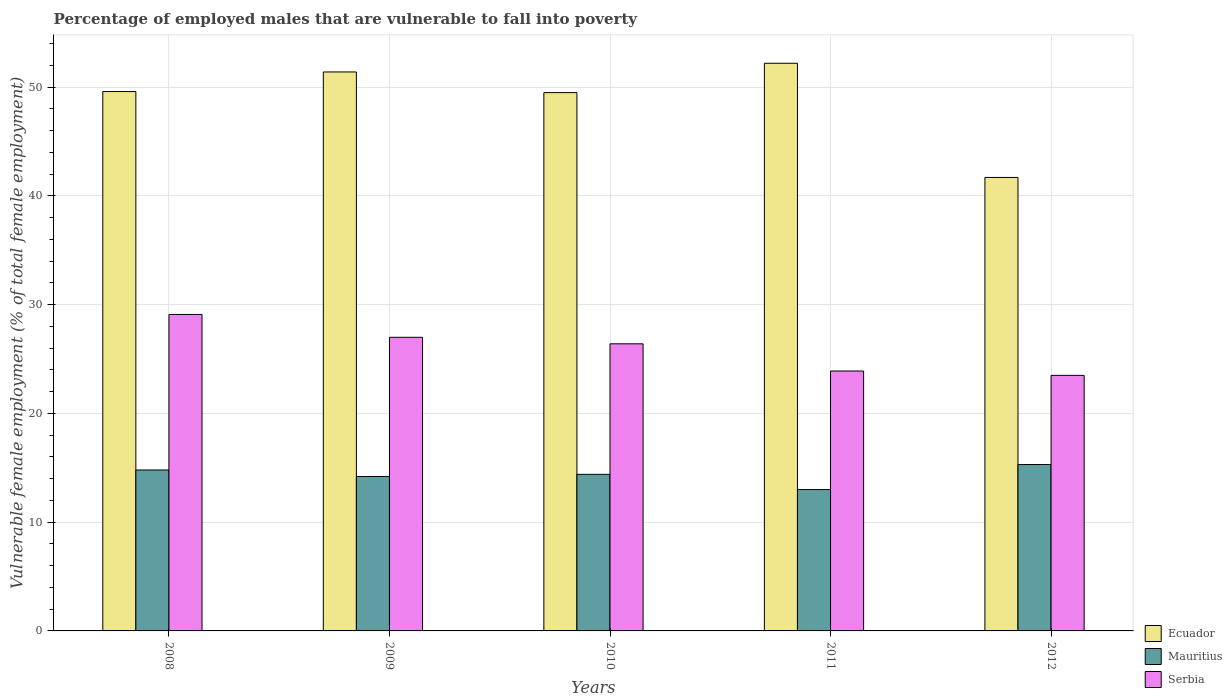How many different coloured bars are there?
Ensure brevity in your answer.  3. How many groups of bars are there?
Offer a terse response. 5. Are the number of bars on each tick of the X-axis equal?
Provide a succinct answer. Yes. In how many cases, is the number of bars for a given year not equal to the number of legend labels?
Provide a succinct answer. 0. What is the percentage of employed males who are vulnerable to fall into poverty in Serbia in 2009?
Your answer should be very brief. 27. Across all years, what is the maximum percentage of employed males who are vulnerable to fall into poverty in Serbia?
Make the answer very short. 29.1. In which year was the percentage of employed males who are vulnerable to fall into poverty in Ecuador maximum?
Give a very brief answer. 2011. What is the total percentage of employed males who are vulnerable to fall into poverty in Serbia in the graph?
Make the answer very short. 129.9. What is the difference between the percentage of employed males who are vulnerable to fall into poverty in Mauritius in 2009 and that in 2011?
Your response must be concise. 1.2. What is the difference between the percentage of employed males who are vulnerable to fall into poverty in Mauritius in 2010 and the percentage of employed males who are vulnerable to fall into poverty in Ecuador in 2012?
Your response must be concise. -27.3. What is the average percentage of employed males who are vulnerable to fall into poverty in Mauritius per year?
Your answer should be very brief. 14.34. In the year 2011, what is the difference between the percentage of employed males who are vulnerable to fall into poverty in Serbia and percentage of employed males who are vulnerable to fall into poverty in Mauritius?
Your answer should be compact. 10.9. What is the ratio of the percentage of employed males who are vulnerable to fall into poverty in Mauritius in 2008 to that in 2009?
Ensure brevity in your answer.  1.04. What is the difference between the highest and the second highest percentage of employed males who are vulnerable to fall into poverty in Serbia?
Your answer should be very brief. 2.1. What is the difference between the highest and the lowest percentage of employed males who are vulnerable to fall into poverty in Serbia?
Offer a very short reply. 5.6. In how many years, is the percentage of employed males who are vulnerable to fall into poverty in Serbia greater than the average percentage of employed males who are vulnerable to fall into poverty in Serbia taken over all years?
Offer a terse response. 3. What does the 1st bar from the left in 2008 represents?
Your answer should be very brief. Ecuador. What does the 3rd bar from the right in 2012 represents?
Offer a terse response. Ecuador. How many bars are there?
Your response must be concise. 15. Does the graph contain grids?
Offer a very short reply. Yes. What is the title of the graph?
Your answer should be compact. Percentage of employed males that are vulnerable to fall into poverty. What is the label or title of the Y-axis?
Provide a short and direct response. Vulnerable female employment (% of total female employment). What is the Vulnerable female employment (% of total female employment) in Ecuador in 2008?
Give a very brief answer. 49.6. What is the Vulnerable female employment (% of total female employment) of Mauritius in 2008?
Offer a very short reply. 14.8. What is the Vulnerable female employment (% of total female employment) in Serbia in 2008?
Keep it short and to the point. 29.1. What is the Vulnerable female employment (% of total female employment) in Ecuador in 2009?
Provide a succinct answer. 51.4. What is the Vulnerable female employment (% of total female employment) in Mauritius in 2009?
Offer a very short reply. 14.2. What is the Vulnerable female employment (% of total female employment) of Ecuador in 2010?
Provide a short and direct response. 49.5. What is the Vulnerable female employment (% of total female employment) in Mauritius in 2010?
Your answer should be very brief. 14.4. What is the Vulnerable female employment (% of total female employment) in Serbia in 2010?
Keep it short and to the point. 26.4. What is the Vulnerable female employment (% of total female employment) in Ecuador in 2011?
Provide a short and direct response. 52.2. What is the Vulnerable female employment (% of total female employment) in Serbia in 2011?
Give a very brief answer. 23.9. What is the Vulnerable female employment (% of total female employment) of Ecuador in 2012?
Your response must be concise. 41.7. What is the Vulnerable female employment (% of total female employment) in Mauritius in 2012?
Make the answer very short. 15.3. What is the Vulnerable female employment (% of total female employment) of Serbia in 2012?
Your answer should be very brief. 23.5. Across all years, what is the maximum Vulnerable female employment (% of total female employment) of Ecuador?
Make the answer very short. 52.2. Across all years, what is the maximum Vulnerable female employment (% of total female employment) in Mauritius?
Offer a very short reply. 15.3. Across all years, what is the maximum Vulnerable female employment (% of total female employment) in Serbia?
Keep it short and to the point. 29.1. Across all years, what is the minimum Vulnerable female employment (% of total female employment) in Ecuador?
Provide a short and direct response. 41.7. Across all years, what is the minimum Vulnerable female employment (% of total female employment) of Mauritius?
Offer a terse response. 13. Across all years, what is the minimum Vulnerable female employment (% of total female employment) of Serbia?
Provide a succinct answer. 23.5. What is the total Vulnerable female employment (% of total female employment) of Ecuador in the graph?
Your answer should be very brief. 244.4. What is the total Vulnerable female employment (% of total female employment) of Mauritius in the graph?
Offer a terse response. 71.7. What is the total Vulnerable female employment (% of total female employment) in Serbia in the graph?
Provide a short and direct response. 129.9. What is the difference between the Vulnerable female employment (% of total female employment) of Ecuador in 2008 and that in 2009?
Keep it short and to the point. -1.8. What is the difference between the Vulnerable female employment (% of total female employment) in Mauritius in 2008 and that in 2009?
Give a very brief answer. 0.6. What is the difference between the Vulnerable female employment (% of total female employment) in Ecuador in 2008 and that in 2010?
Give a very brief answer. 0.1. What is the difference between the Vulnerable female employment (% of total female employment) in Ecuador in 2008 and that in 2011?
Provide a short and direct response. -2.6. What is the difference between the Vulnerable female employment (% of total female employment) of Serbia in 2008 and that in 2011?
Make the answer very short. 5.2. What is the difference between the Vulnerable female employment (% of total female employment) in Mauritius in 2008 and that in 2012?
Your answer should be compact. -0.5. What is the difference between the Vulnerable female employment (% of total female employment) of Serbia in 2008 and that in 2012?
Offer a terse response. 5.6. What is the difference between the Vulnerable female employment (% of total female employment) of Ecuador in 2009 and that in 2010?
Provide a succinct answer. 1.9. What is the difference between the Vulnerable female employment (% of total female employment) in Mauritius in 2009 and that in 2010?
Offer a terse response. -0.2. What is the difference between the Vulnerable female employment (% of total female employment) in Mauritius in 2009 and that in 2011?
Offer a terse response. 1.2. What is the difference between the Vulnerable female employment (% of total female employment) of Serbia in 2009 and that in 2011?
Provide a short and direct response. 3.1. What is the difference between the Vulnerable female employment (% of total female employment) in Serbia in 2009 and that in 2012?
Ensure brevity in your answer.  3.5. What is the difference between the Vulnerable female employment (% of total female employment) of Serbia in 2010 and that in 2011?
Your answer should be compact. 2.5. What is the difference between the Vulnerable female employment (% of total female employment) in Mauritius in 2010 and that in 2012?
Give a very brief answer. -0.9. What is the difference between the Vulnerable female employment (% of total female employment) in Ecuador in 2011 and that in 2012?
Keep it short and to the point. 10.5. What is the difference between the Vulnerable female employment (% of total female employment) in Serbia in 2011 and that in 2012?
Ensure brevity in your answer.  0.4. What is the difference between the Vulnerable female employment (% of total female employment) of Ecuador in 2008 and the Vulnerable female employment (% of total female employment) of Mauritius in 2009?
Provide a succinct answer. 35.4. What is the difference between the Vulnerable female employment (% of total female employment) of Ecuador in 2008 and the Vulnerable female employment (% of total female employment) of Serbia in 2009?
Provide a succinct answer. 22.6. What is the difference between the Vulnerable female employment (% of total female employment) in Ecuador in 2008 and the Vulnerable female employment (% of total female employment) in Mauritius in 2010?
Make the answer very short. 35.2. What is the difference between the Vulnerable female employment (% of total female employment) of Ecuador in 2008 and the Vulnerable female employment (% of total female employment) of Serbia in 2010?
Provide a succinct answer. 23.2. What is the difference between the Vulnerable female employment (% of total female employment) in Mauritius in 2008 and the Vulnerable female employment (% of total female employment) in Serbia in 2010?
Make the answer very short. -11.6. What is the difference between the Vulnerable female employment (% of total female employment) of Ecuador in 2008 and the Vulnerable female employment (% of total female employment) of Mauritius in 2011?
Your answer should be very brief. 36.6. What is the difference between the Vulnerable female employment (% of total female employment) of Ecuador in 2008 and the Vulnerable female employment (% of total female employment) of Serbia in 2011?
Give a very brief answer. 25.7. What is the difference between the Vulnerable female employment (% of total female employment) in Mauritius in 2008 and the Vulnerable female employment (% of total female employment) in Serbia in 2011?
Offer a terse response. -9.1. What is the difference between the Vulnerable female employment (% of total female employment) in Ecuador in 2008 and the Vulnerable female employment (% of total female employment) in Mauritius in 2012?
Provide a short and direct response. 34.3. What is the difference between the Vulnerable female employment (% of total female employment) in Ecuador in 2008 and the Vulnerable female employment (% of total female employment) in Serbia in 2012?
Give a very brief answer. 26.1. What is the difference between the Vulnerable female employment (% of total female employment) in Mauritius in 2009 and the Vulnerable female employment (% of total female employment) in Serbia in 2010?
Keep it short and to the point. -12.2. What is the difference between the Vulnerable female employment (% of total female employment) in Ecuador in 2009 and the Vulnerable female employment (% of total female employment) in Mauritius in 2011?
Your answer should be very brief. 38.4. What is the difference between the Vulnerable female employment (% of total female employment) of Mauritius in 2009 and the Vulnerable female employment (% of total female employment) of Serbia in 2011?
Provide a short and direct response. -9.7. What is the difference between the Vulnerable female employment (% of total female employment) in Ecuador in 2009 and the Vulnerable female employment (% of total female employment) in Mauritius in 2012?
Offer a very short reply. 36.1. What is the difference between the Vulnerable female employment (% of total female employment) of Ecuador in 2009 and the Vulnerable female employment (% of total female employment) of Serbia in 2012?
Provide a short and direct response. 27.9. What is the difference between the Vulnerable female employment (% of total female employment) in Mauritius in 2009 and the Vulnerable female employment (% of total female employment) in Serbia in 2012?
Ensure brevity in your answer.  -9.3. What is the difference between the Vulnerable female employment (% of total female employment) of Ecuador in 2010 and the Vulnerable female employment (% of total female employment) of Mauritius in 2011?
Your answer should be very brief. 36.5. What is the difference between the Vulnerable female employment (% of total female employment) in Ecuador in 2010 and the Vulnerable female employment (% of total female employment) in Serbia in 2011?
Provide a succinct answer. 25.6. What is the difference between the Vulnerable female employment (% of total female employment) of Ecuador in 2010 and the Vulnerable female employment (% of total female employment) of Mauritius in 2012?
Ensure brevity in your answer.  34.2. What is the difference between the Vulnerable female employment (% of total female employment) of Ecuador in 2010 and the Vulnerable female employment (% of total female employment) of Serbia in 2012?
Offer a very short reply. 26. What is the difference between the Vulnerable female employment (% of total female employment) of Mauritius in 2010 and the Vulnerable female employment (% of total female employment) of Serbia in 2012?
Offer a very short reply. -9.1. What is the difference between the Vulnerable female employment (% of total female employment) of Ecuador in 2011 and the Vulnerable female employment (% of total female employment) of Mauritius in 2012?
Provide a short and direct response. 36.9. What is the difference between the Vulnerable female employment (% of total female employment) of Ecuador in 2011 and the Vulnerable female employment (% of total female employment) of Serbia in 2012?
Give a very brief answer. 28.7. What is the difference between the Vulnerable female employment (% of total female employment) in Mauritius in 2011 and the Vulnerable female employment (% of total female employment) in Serbia in 2012?
Provide a short and direct response. -10.5. What is the average Vulnerable female employment (% of total female employment) in Ecuador per year?
Give a very brief answer. 48.88. What is the average Vulnerable female employment (% of total female employment) of Mauritius per year?
Make the answer very short. 14.34. What is the average Vulnerable female employment (% of total female employment) in Serbia per year?
Your response must be concise. 25.98. In the year 2008, what is the difference between the Vulnerable female employment (% of total female employment) of Ecuador and Vulnerable female employment (% of total female employment) of Mauritius?
Provide a short and direct response. 34.8. In the year 2008, what is the difference between the Vulnerable female employment (% of total female employment) in Mauritius and Vulnerable female employment (% of total female employment) in Serbia?
Make the answer very short. -14.3. In the year 2009, what is the difference between the Vulnerable female employment (% of total female employment) of Ecuador and Vulnerable female employment (% of total female employment) of Mauritius?
Your answer should be compact. 37.2. In the year 2009, what is the difference between the Vulnerable female employment (% of total female employment) of Ecuador and Vulnerable female employment (% of total female employment) of Serbia?
Provide a succinct answer. 24.4. In the year 2009, what is the difference between the Vulnerable female employment (% of total female employment) of Mauritius and Vulnerable female employment (% of total female employment) of Serbia?
Provide a succinct answer. -12.8. In the year 2010, what is the difference between the Vulnerable female employment (% of total female employment) of Ecuador and Vulnerable female employment (% of total female employment) of Mauritius?
Give a very brief answer. 35.1. In the year 2010, what is the difference between the Vulnerable female employment (% of total female employment) of Ecuador and Vulnerable female employment (% of total female employment) of Serbia?
Provide a short and direct response. 23.1. In the year 2011, what is the difference between the Vulnerable female employment (% of total female employment) in Ecuador and Vulnerable female employment (% of total female employment) in Mauritius?
Provide a short and direct response. 39.2. In the year 2011, what is the difference between the Vulnerable female employment (% of total female employment) of Ecuador and Vulnerable female employment (% of total female employment) of Serbia?
Make the answer very short. 28.3. In the year 2011, what is the difference between the Vulnerable female employment (% of total female employment) in Mauritius and Vulnerable female employment (% of total female employment) in Serbia?
Make the answer very short. -10.9. In the year 2012, what is the difference between the Vulnerable female employment (% of total female employment) of Ecuador and Vulnerable female employment (% of total female employment) of Mauritius?
Keep it short and to the point. 26.4. In the year 2012, what is the difference between the Vulnerable female employment (% of total female employment) of Mauritius and Vulnerable female employment (% of total female employment) of Serbia?
Provide a short and direct response. -8.2. What is the ratio of the Vulnerable female employment (% of total female employment) of Ecuador in 2008 to that in 2009?
Your response must be concise. 0.96. What is the ratio of the Vulnerable female employment (% of total female employment) of Mauritius in 2008 to that in 2009?
Your answer should be compact. 1.04. What is the ratio of the Vulnerable female employment (% of total female employment) of Serbia in 2008 to that in 2009?
Provide a short and direct response. 1.08. What is the ratio of the Vulnerable female employment (% of total female employment) of Ecuador in 2008 to that in 2010?
Make the answer very short. 1. What is the ratio of the Vulnerable female employment (% of total female employment) in Mauritius in 2008 to that in 2010?
Your answer should be very brief. 1.03. What is the ratio of the Vulnerable female employment (% of total female employment) of Serbia in 2008 to that in 2010?
Offer a very short reply. 1.1. What is the ratio of the Vulnerable female employment (% of total female employment) of Ecuador in 2008 to that in 2011?
Your answer should be compact. 0.95. What is the ratio of the Vulnerable female employment (% of total female employment) of Mauritius in 2008 to that in 2011?
Offer a very short reply. 1.14. What is the ratio of the Vulnerable female employment (% of total female employment) in Serbia in 2008 to that in 2011?
Make the answer very short. 1.22. What is the ratio of the Vulnerable female employment (% of total female employment) in Ecuador in 2008 to that in 2012?
Provide a succinct answer. 1.19. What is the ratio of the Vulnerable female employment (% of total female employment) of Mauritius in 2008 to that in 2012?
Your answer should be compact. 0.97. What is the ratio of the Vulnerable female employment (% of total female employment) in Serbia in 2008 to that in 2012?
Keep it short and to the point. 1.24. What is the ratio of the Vulnerable female employment (% of total female employment) of Ecuador in 2009 to that in 2010?
Your answer should be very brief. 1.04. What is the ratio of the Vulnerable female employment (% of total female employment) of Mauritius in 2009 to that in 2010?
Offer a very short reply. 0.99. What is the ratio of the Vulnerable female employment (% of total female employment) in Serbia in 2009 to that in 2010?
Provide a short and direct response. 1.02. What is the ratio of the Vulnerable female employment (% of total female employment) of Ecuador in 2009 to that in 2011?
Provide a short and direct response. 0.98. What is the ratio of the Vulnerable female employment (% of total female employment) of Mauritius in 2009 to that in 2011?
Give a very brief answer. 1.09. What is the ratio of the Vulnerable female employment (% of total female employment) of Serbia in 2009 to that in 2011?
Keep it short and to the point. 1.13. What is the ratio of the Vulnerable female employment (% of total female employment) of Ecuador in 2009 to that in 2012?
Keep it short and to the point. 1.23. What is the ratio of the Vulnerable female employment (% of total female employment) in Mauritius in 2009 to that in 2012?
Offer a terse response. 0.93. What is the ratio of the Vulnerable female employment (% of total female employment) of Serbia in 2009 to that in 2012?
Provide a short and direct response. 1.15. What is the ratio of the Vulnerable female employment (% of total female employment) of Ecuador in 2010 to that in 2011?
Provide a short and direct response. 0.95. What is the ratio of the Vulnerable female employment (% of total female employment) in Mauritius in 2010 to that in 2011?
Keep it short and to the point. 1.11. What is the ratio of the Vulnerable female employment (% of total female employment) of Serbia in 2010 to that in 2011?
Offer a very short reply. 1.1. What is the ratio of the Vulnerable female employment (% of total female employment) in Ecuador in 2010 to that in 2012?
Give a very brief answer. 1.19. What is the ratio of the Vulnerable female employment (% of total female employment) of Mauritius in 2010 to that in 2012?
Offer a very short reply. 0.94. What is the ratio of the Vulnerable female employment (% of total female employment) of Serbia in 2010 to that in 2012?
Make the answer very short. 1.12. What is the ratio of the Vulnerable female employment (% of total female employment) in Ecuador in 2011 to that in 2012?
Ensure brevity in your answer.  1.25. What is the ratio of the Vulnerable female employment (% of total female employment) of Mauritius in 2011 to that in 2012?
Provide a short and direct response. 0.85. What is the difference between the highest and the second highest Vulnerable female employment (% of total female employment) of Serbia?
Ensure brevity in your answer.  2.1. What is the difference between the highest and the lowest Vulnerable female employment (% of total female employment) in Ecuador?
Keep it short and to the point. 10.5. What is the difference between the highest and the lowest Vulnerable female employment (% of total female employment) of Mauritius?
Offer a terse response. 2.3. 